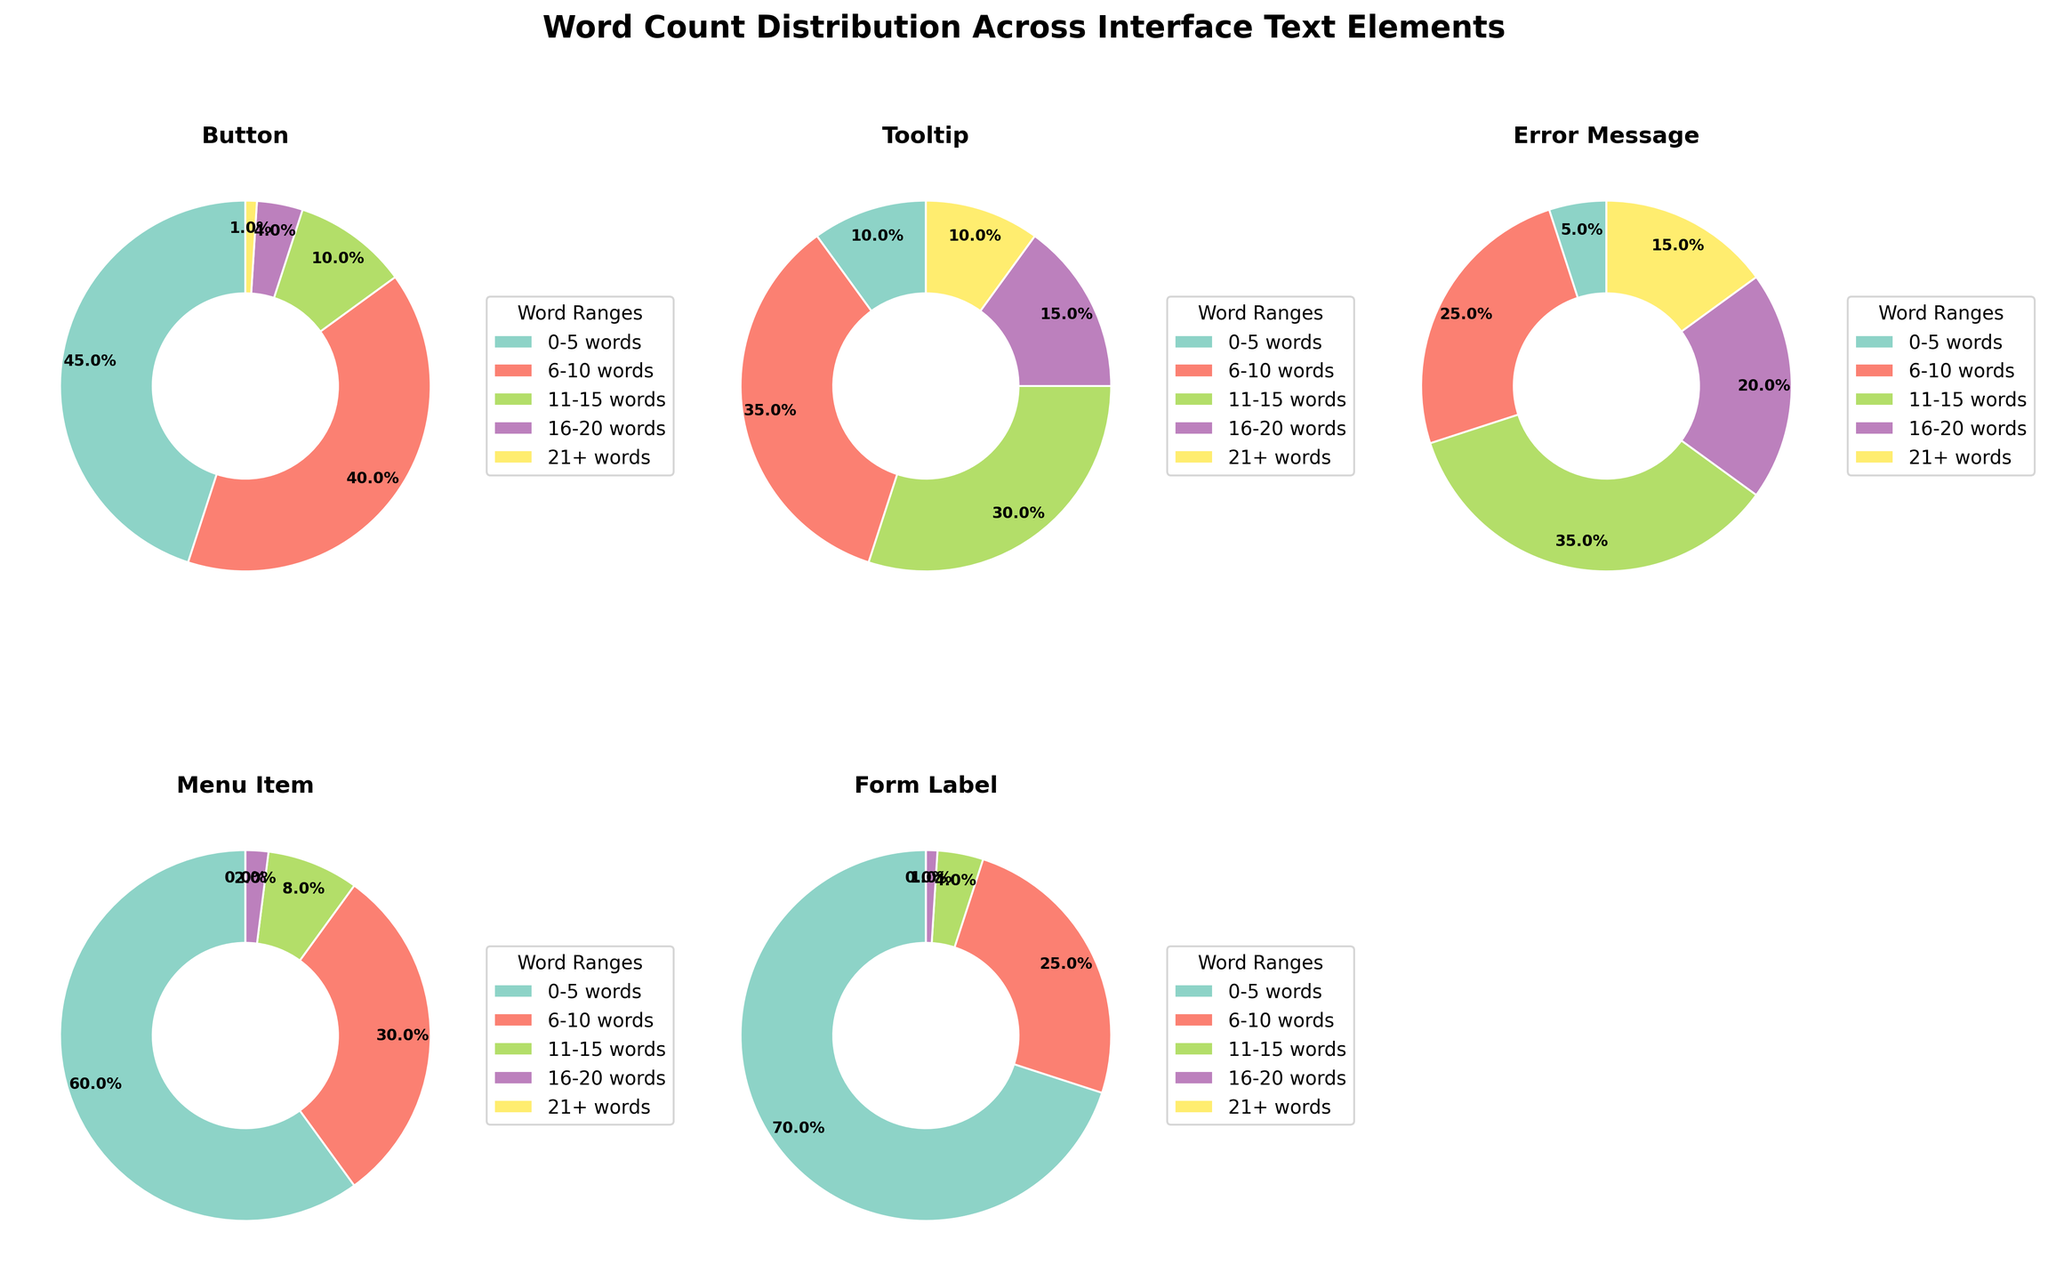What is the title of the figure? The title is typically located at the top of the figure, and the title of this figure is "Word Count Distribution Across Interface Text Elements."
Answer: Word Count Distribution Across Interface Text Elements Which interface text element has the highest percentage for the "0-5 words" category? By looking at the pie charts for each interface text element, the "Form Label" has the highest percentage with 70% in the "0-5 words" category.
Answer: Form Label What percentage of "Tooltip" text elements contain "11-15 words"? Referring to the pie chart for "Tooltip," the segment for "11-15 words" is 30%.
Answer: 30% Compare the percentage of "Error Message" text elements that have "16-20 words" to "Menu Item" text elements with the same word count range. Which is higher? The pie chart for "Error Message" shows 20% for the "16-20 words" category, while "Menu Item" shows 2%. Therefore, "Error Message" is higher.
Answer: Error Message Is it true that none of the "Menu Item" texts have more than 20 words? Examining the pie chart for "Menu Item," there is no segment for "21+ words," confirming that none of the "Menu Item" texts exceed 20 words.
Answer: True What is the combined percentage of "Button" text elements with "11-15 words" and "16-20 words"? For "Button," the "11-15 words" category is 10% and "16-20 words" category is 4%. Adding them together, 10% + 4% = 14%.
Answer: 14% Among "Button" and "Form Label" text elements, which has a higher percentage of "6-10 words"? The pie chart for "Button" shows 40% for "6-10 words," whereas "Form Label" shows 25%. Therefore, "Button" has a higher percentage.
Answer: Button Is there any interface text element that has a majority percentage (more than 50%) in the "6-10 words" category? By examining each pie chart, none of the interface text elements have more than 50% in the "6-10 words" category.
Answer: No What percentage of "Error Message" text elements are more than 10 words long? Summing up "11-15 words" (35%), "16-20 words" (20%), and "21+ words" (15%), the total is 35% + 20% + 15% = 70%.
Answer: 70% How does the percentage of "Tooltip" text elements in the "21+ words" category compare to that of "Button" text elements in the same category? "Tooltip" has 10% in the "21+ words" category, whereas "Button" has 1%, making the percentage for "Tooltip" higher.
Answer: Tooltip 